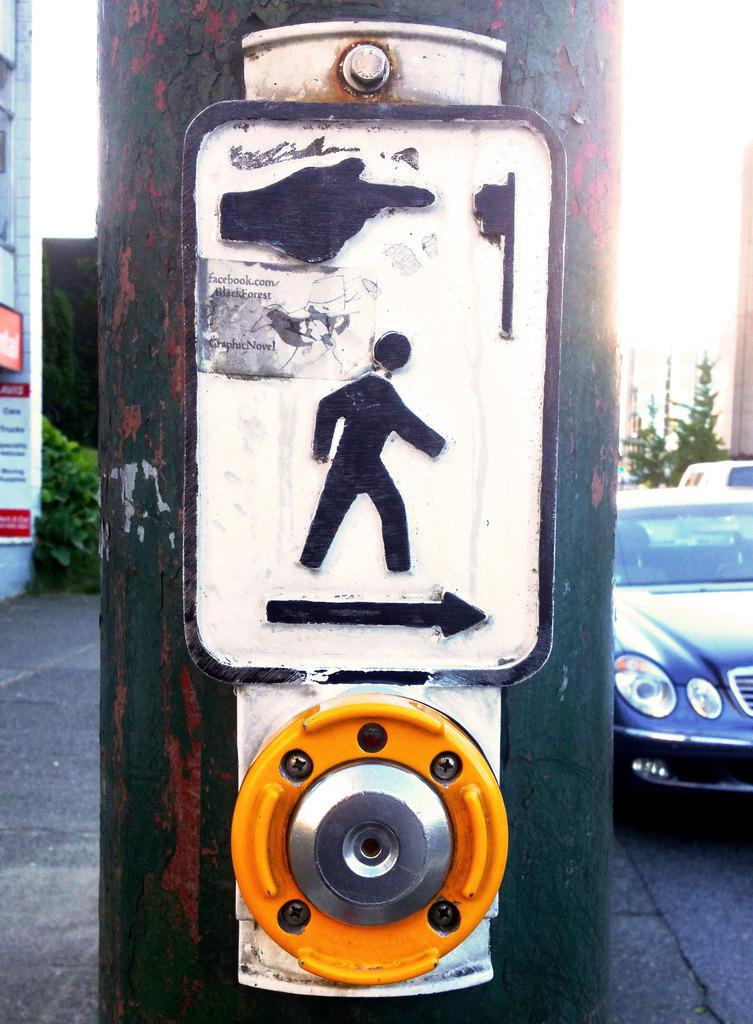What is the main object in the center of the image? There is a pole in the center of the image. What information is provided on the pole? A direction mark is present on the pole. What type of vegetation can be seen in the background? There are shrubs and trees in the background. What can be seen on the road in the background? There is a car visible on the road in the background. How are the men playing in the waves in the image? There are no men or waves present in the image; it features a pole with a direction mark, shrubs and trees in the background, and a car visible on the road. 